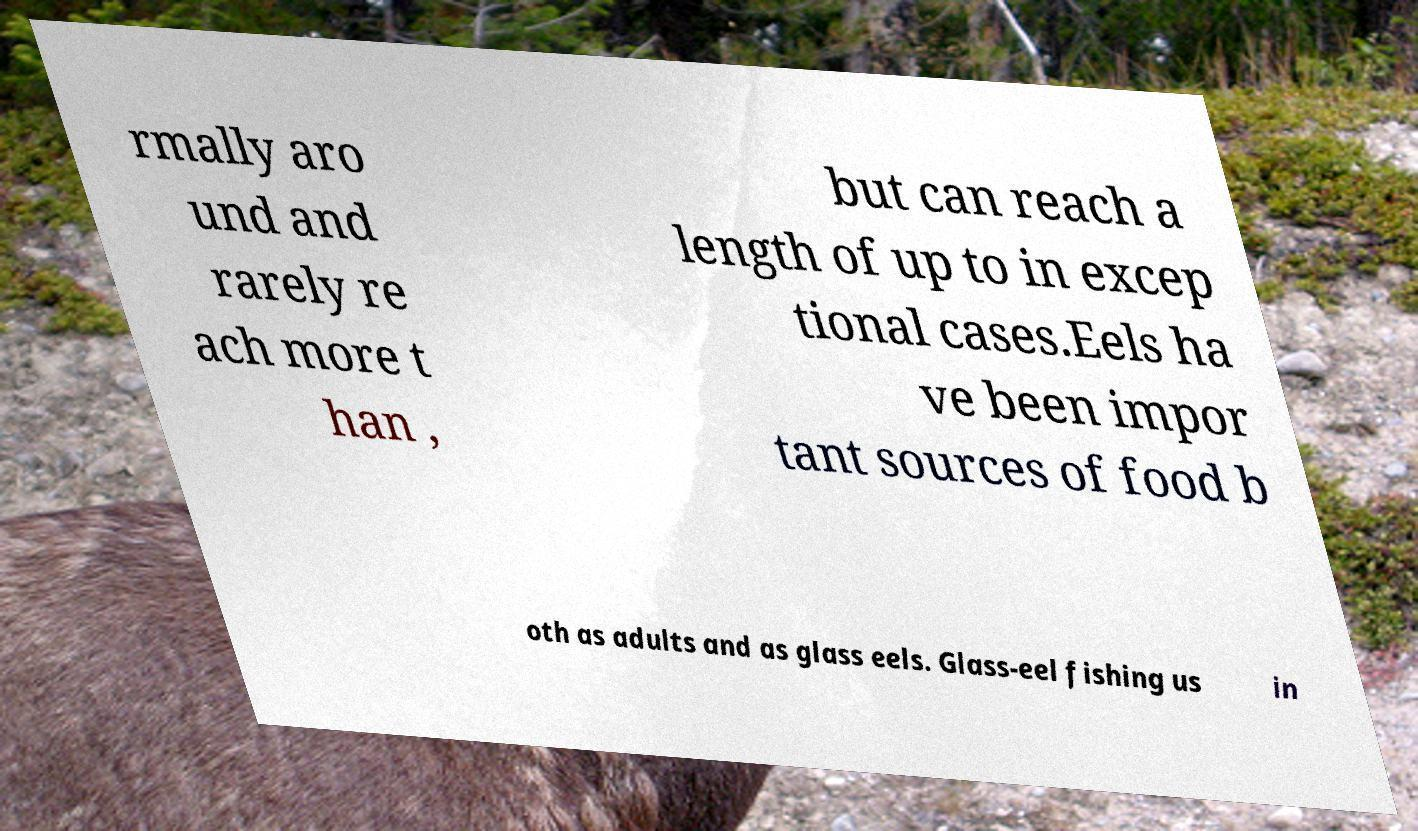Could you assist in decoding the text presented in this image and type it out clearly? rmally aro und and rarely re ach more t han , but can reach a length of up to in excep tional cases.Eels ha ve been impor tant sources of food b oth as adults and as glass eels. Glass-eel fishing us in 